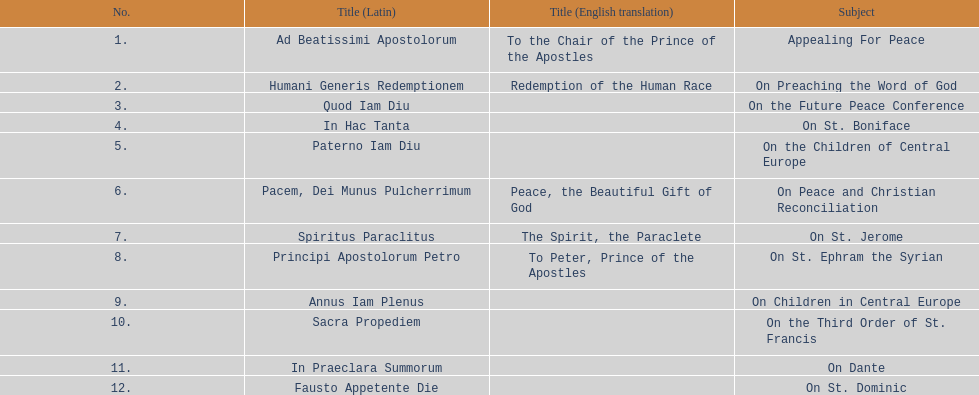Can you give me this table as a dict? {'header': ['No.', 'Title (Latin)', 'Title (English translation)', 'Subject'], 'rows': [['1.', 'Ad Beatissimi Apostolorum', 'To the Chair of the Prince of the Apostles', 'Appealing For Peace'], ['2.', 'Humani Generis Redemptionem', 'Redemption of the Human Race', 'On Preaching the Word of God'], ['3.', 'Quod Iam Diu', '', 'On the Future Peace Conference'], ['4.', 'In Hac Tanta', '', 'On St. Boniface'], ['5.', 'Paterno Iam Diu', '', 'On the Children of Central Europe'], ['6.', 'Pacem, Dei Munus Pulcherrimum', 'Peace, the Beautiful Gift of God', 'On Peace and Christian Reconciliation'], ['7.', 'Spiritus Paraclitus', 'The Spirit, the Paraclete', 'On St. Jerome'], ['8.', 'Principi Apostolorum Petro', 'To Peter, Prince of the Apostles', 'On St. Ephram the Syrian'], ['9.', 'Annus Iam Plenus', '', 'On Children in Central Europe'], ['10.', 'Sacra Propediem', '', 'On the Third Order of St. Francis'], ['11.', 'In Praeclara Summorum', '', 'On Dante'], ['12.', 'Fausto Appetente Die', '', 'On St. Dominic']]} In 1921, how many encyclicals were issued apart from those in january? 2. 